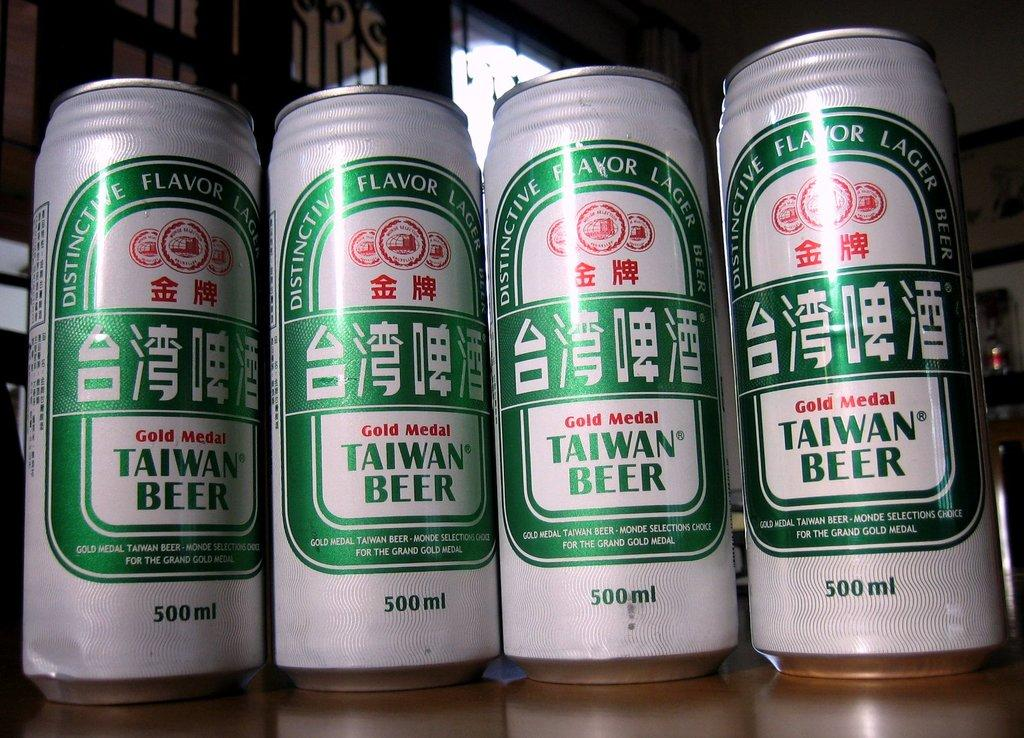<image>
Relay a brief, clear account of the picture shown. A white and green can contains gold metal Taiwan beer. 